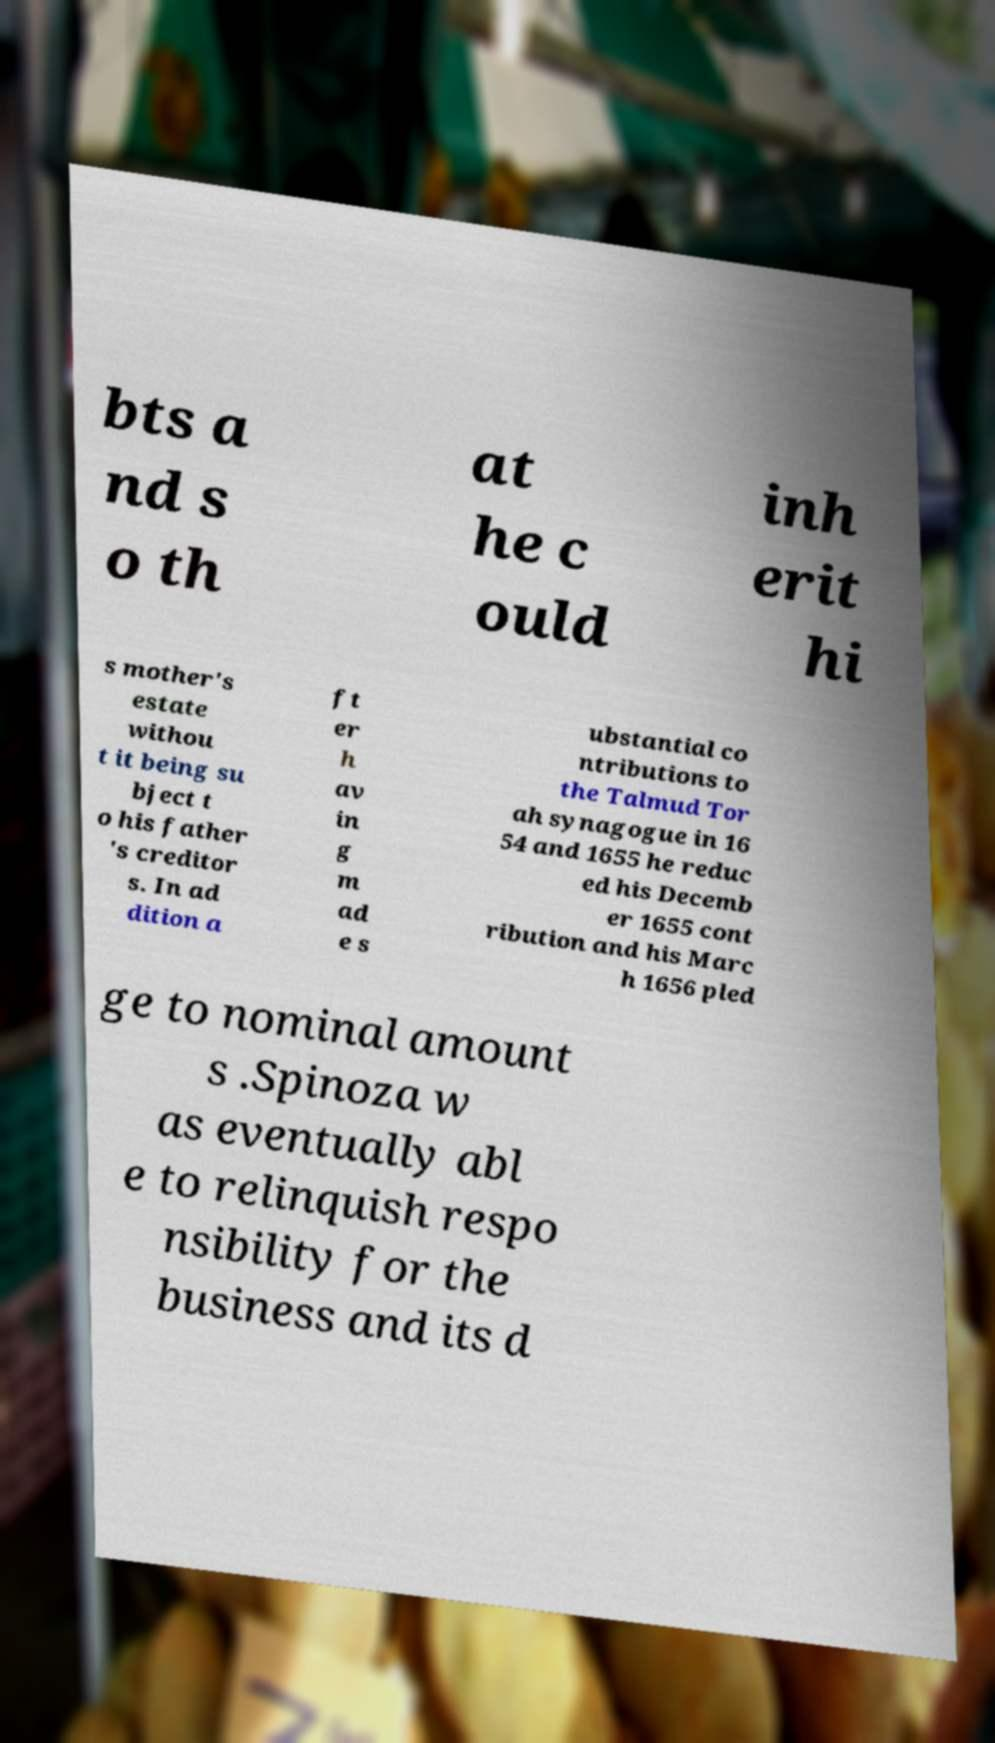Please read and relay the text visible in this image. What does it say? bts a nd s o th at he c ould inh erit hi s mother's estate withou t it being su bject t o his father 's creditor s. In ad dition a ft er h av in g m ad e s ubstantial co ntributions to the Talmud Tor ah synagogue in 16 54 and 1655 he reduc ed his Decemb er 1655 cont ribution and his Marc h 1656 pled ge to nominal amount s .Spinoza w as eventually abl e to relinquish respo nsibility for the business and its d 